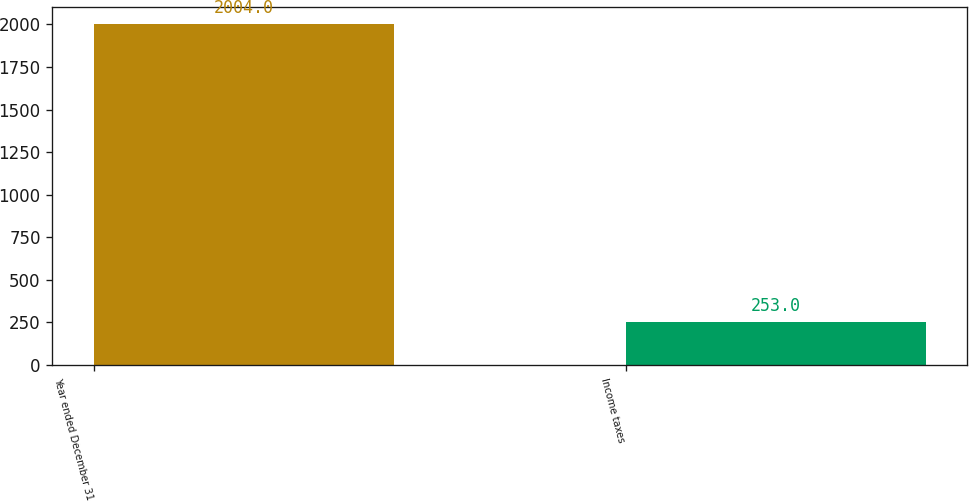Convert chart to OTSL. <chart><loc_0><loc_0><loc_500><loc_500><bar_chart><fcel>Year ended December 31<fcel>Income taxes<nl><fcel>2004<fcel>253<nl></chart> 